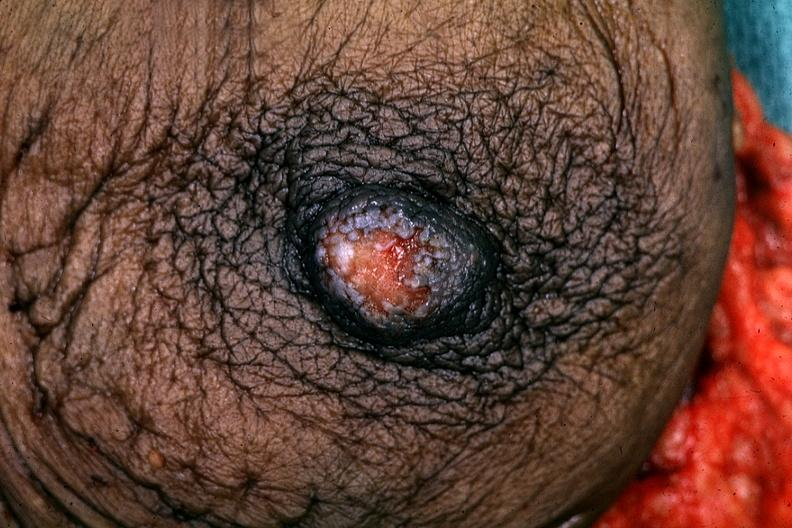does this image show excised breast good example?
Answer the question using a single word or phrase. Yes 